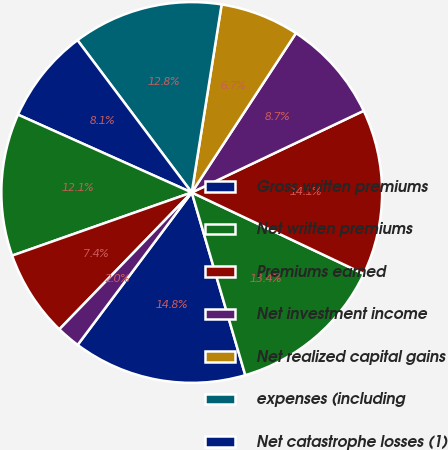Convert chart to OTSL. <chart><loc_0><loc_0><loc_500><loc_500><pie_chart><fcel>Gross written premiums<fcel>Net written premiums<fcel>Premiums earned<fcel>Net investment income<fcel>Net realized capital gains<fcel>expenses (including<fcel>Net catastrophe losses (1)<fcel>Commission brokerage taxes and<fcel>Other underwriting expenses<fcel>Corporate expenses<nl><fcel>14.76%<fcel>13.42%<fcel>14.09%<fcel>8.72%<fcel>6.71%<fcel>12.75%<fcel>8.05%<fcel>12.08%<fcel>7.38%<fcel>2.01%<nl></chart> 